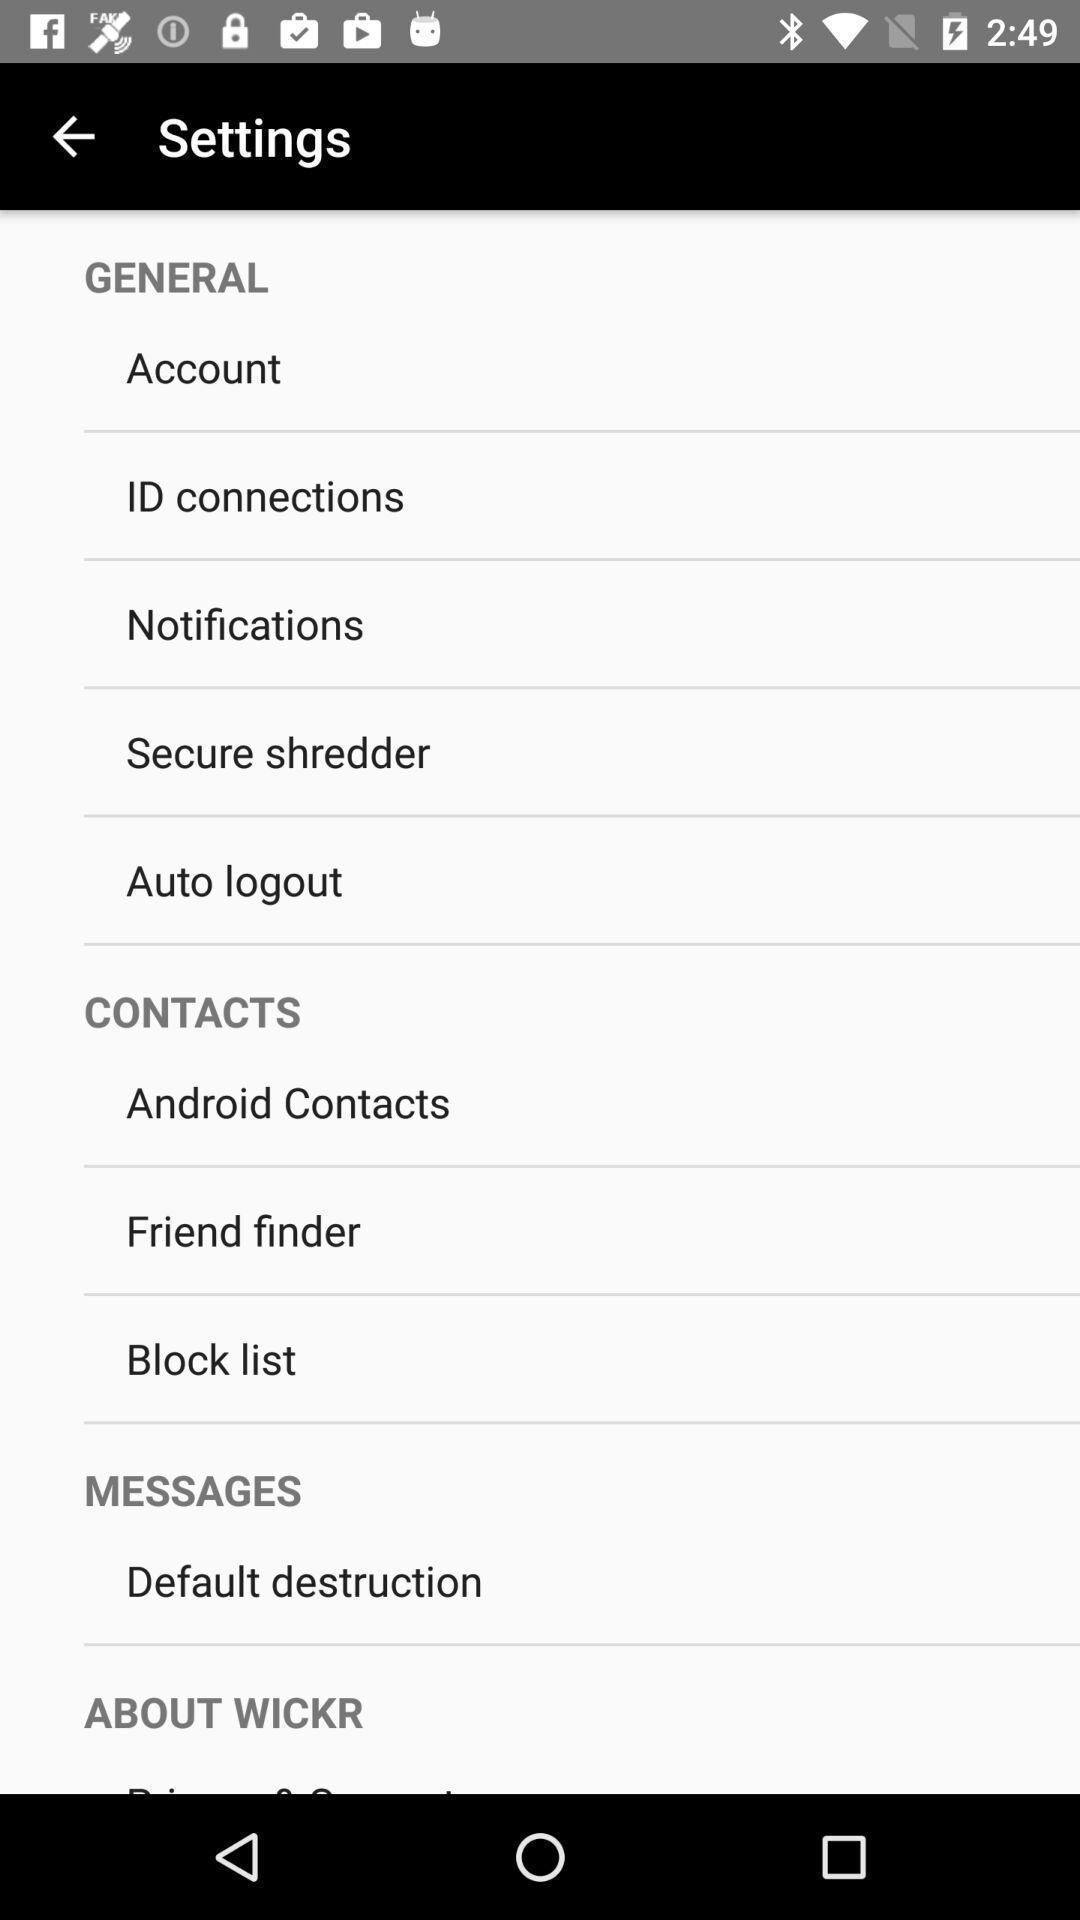Give me a summary of this screen capture. Settings page. 